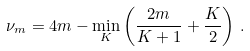<formula> <loc_0><loc_0><loc_500><loc_500>\nu _ { m } = 4 m - \min _ { K } \left ( \frac { 2 m } { K + 1 } + \frac { K } { 2 } \right ) \, .</formula> 